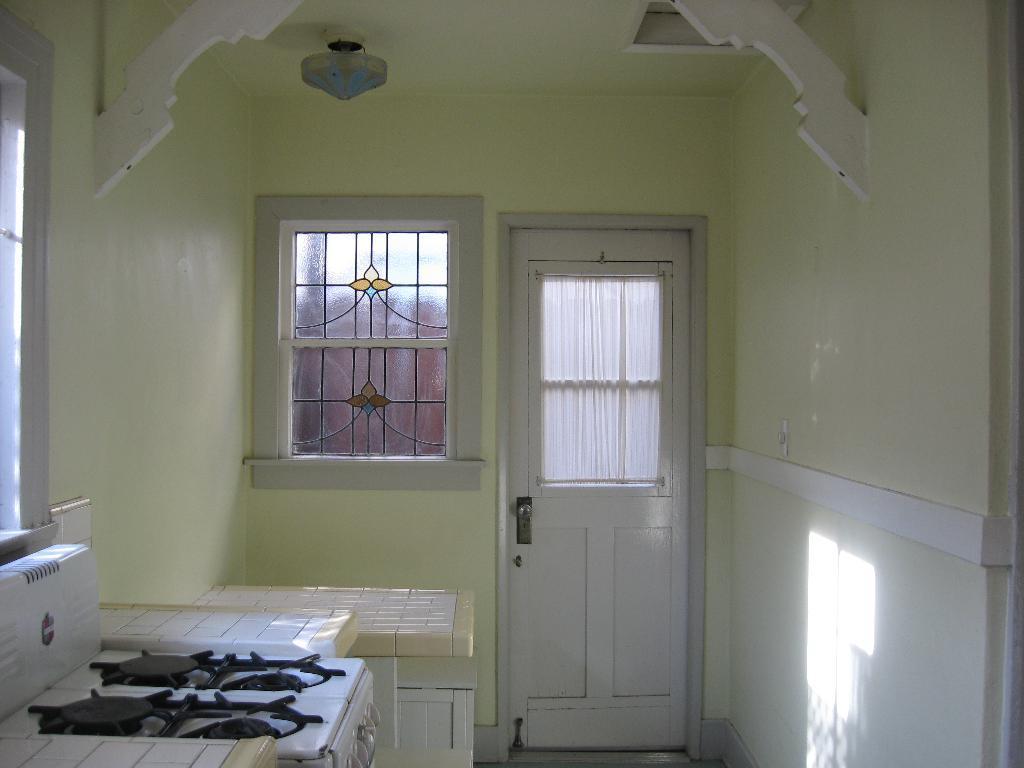In one or two sentences, can you explain what this image depicts? In this picture there is black and white colored stove on the left side and There is wall on the right side. And there is a door and a window in the background. And the light is at the top. 